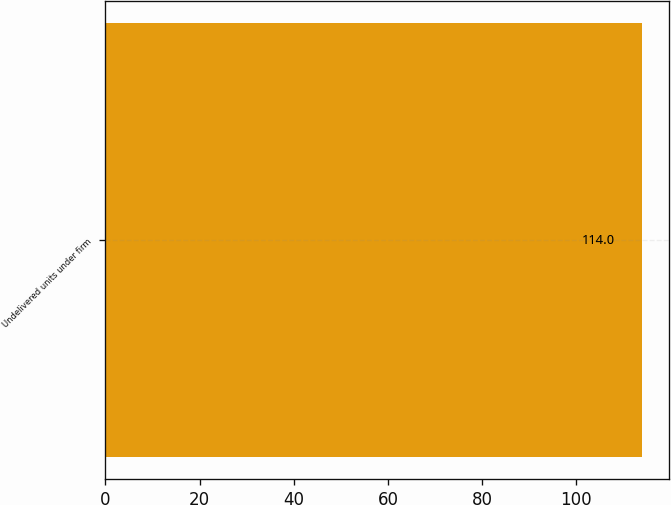<chart> <loc_0><loc_0><loc_500><loc_500><bar_chart><fcel>Undelivered units under firm<nl><fcel>114<nl></chart> 